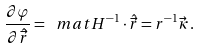Convert formula to latex. <formula><loc_0><loc_0><loc_500><loc_500>\frac { \partial \varphi } { \partial \hat { \vec { r } } } = \ m a t { H } ^ { - 1 } \cdot \hat { \vec { r } } = r ^ { - 1 } \vec { \kappa } \, .</formula> 